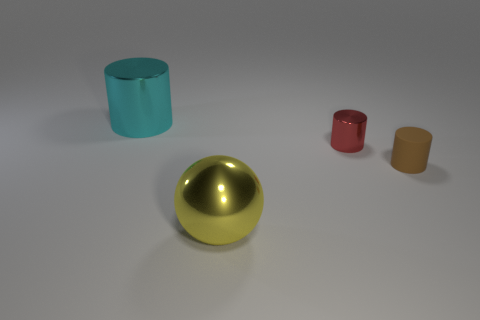Add 4 small cyan matte balls. How many objects exist? 8 Subtract all spheres. How many objects are left? 3 Subtract all big metal spheres. Subtract all small blue metallic objects. How many objects are left? 3 Add 1 tiny red things. How many tiny red things are left? 2 Add 4 small red metal spheres. How many small red metal spheres exist? 4 Subtract 0 red cubes. How many objects are left? 4 